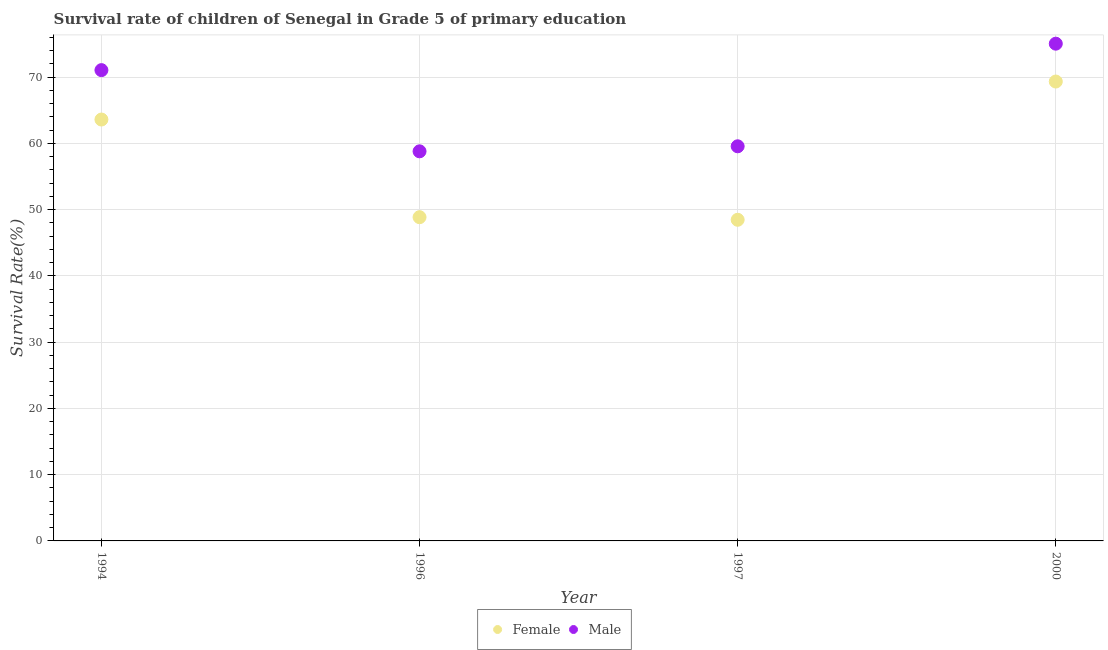How many different coloured dotlines are there?
Ensure brevity in your answer.  2. What is the survival rate of female students in primary education in 1994?
Your answer should be compact. 63.61. Across all years, what is the maximum survival rate of male students in primary education?
Provide a succinct answer. 75.06. Across all years, what is the minimum survival rate of male students in primary education?
Offer a very short reply. 58.81. In which year was the survival rate of male students in primary education maximum?
Ensure brevity in your answer.  2000. What is the total survival rate of female students in primary education in the graph?
Your response must be concise. 230.3. What is the difference between the survival rate of female students in primary education in 1994 and that in 2000?
Your answer should be compact. -5.74. What is the difference between the survival rate of male students in primary education in 2000 and the survival rate of female students in primary education in 1996?
Your response must be concise. 26.19. What is the average survival rate of male students in primary education per year?
Offer a very short reply. 66.13. In the year 1996, what is the difference between the survival rate of female students in primary education and survival rate of male students in primary education?
Your answer should be compact. -9.94. What is the ratio of the survival rate of female students in primary education in 1996 to that in 2000?
Your response must be concise. 0.7. What is the difference between the highest and the second highest survival rate of female students in primary education?
Offer a very short reply. 5.74. What is the difference between the highest and the lowest survival rate of female students in primary education?
Your answer should be very brief. 20.87. Is the survival rate of male students in primary education strictly greater than the survival rate of female students in primary education over the years?
Provide a succinct answer. Yes. Is the survival rate of female students in primary education strictly less than the survival rate of male students in primary education over the years?
Offer a terse response. Yes. What is the difference between two consecutive major ticks on the Y-axis?
Provide a succinct answer. 10. Are the values on the major ticks of Y-axis written in scientific E-notation?
Your response must be concise. No. Does the graph contain any zero values?
Provide a succinct answer. No. Where does the legend appear in the graph?
Offer a terse response. Bottom center. How are the legend labels stacked?
Your response must be concise. Horizontal. What is the title of the graph?
Ensure brevity in your answer.  Survival rate of children of Senegal in Grade 5 of primary education. What is the label or title of the X-axis?
Make the answer very short. Year. What is the label or title of the Y-axis?
Make the answer very short. Survival Rate(%). What is the Survival Rate(%) of Female in 1994?
Keep it short and to the point. 63.61. What is the Survival Rate(%) in Male in 1994?
Your answer should be compact. 71.07. What is the Survival Rate(%) in Female in 1996?
Keep it short and to the point. 48.87. What is the Survival Rate(%) of Male in 1996?
Your answer should be very brief. 58.81. What is the Survival Rate(%) of Female in 1997?
Your response must be concise. 48.48. What is the Survival Rate(%) in Male in 1997?
Keep it short and to the point. 59.57. What is the Survival Rate(%) of Female in 2000?
Your answer should be very brief. 69.34. What is the Survival Rate(%) of Male in 2000?
Offer a terse response. 75.06. Across all years, what is the maximum Survival Rate(%) of Female?
Keep it short and to the point. 69.34. Across all years, what is the maximum Survival Rate(%) in Male?
Make the answer very short. 75.06. Across all years, what is the minimum Survival Rate(%) in Female?
Your answer should be very brief. 48.48. Across all years, what is the minimum Survival Rate(%) of Male?
Make the answer very short. 58.81. What is the total Survival Rate(%) in Female in the graph?
Offer a terse response. 230.3. What is the total Survival Rate(%) of Male in the graph?
Offer a very short reply. 264.5. What is the difference between the Survival Rate(%) of Female in 1994 and that in 1996?
Offer a terse response. 14.74. What is the difference between the Survival Rate(%) in Male in 1994 and that in 1996?
Offer a terse response. 12.26. What is the difference between the Survival Rate(%) in Female in 1994 and that in 1997?
Keep it short and to the point. 15.13. What is the difference between the Survival Rate(%) of Male in 1994 and that in 1997?
Your answer should be compact. 11.5. What is the difference between the Survival Rate(%) in Female in 1994 and that in 2000?
Keep it short and to the point. -5.74. What is the difference between the Survival Rate(%) of Male in 1994 and that in 2000?
Your answer should be compact. -3.99. What is the difference between the Survival Rate(%) in Female in 1996 and that in 1997?
Your answer should be compact. 0.39. What is the difference between the Survival Rate(%) of Male in 1996 and that in 1997?
Offer a terse response. -0.76. What is the difference between the Survival Rate(%) of Female in 1996 and that in 2000?
Your answer should be compact. -20.47. What is the difference between the Survival Rate(%) in Male in 1996 and that in 2000?
Give a very brief answer. -16.25. What is the difference between the Survival Rate(%) in Female in 1997 and that in 2000?
Keep it short and to the point. -20.87. What is the difference between the Survival Rate(%) of Male in 1997 and that in 2000?
Make the answer very short. -15.49. What is the difference between the Survival Rate(%) of Female in 1994 and the Survival Rate(%) of Male in 1996?
Provide a succinct answer. 4.8. What is the difference between the Survival Rate(%) of Female in 1994 and the Survival Rate(%) of Male in 1997?
Your answer should be compact. 4.04. What is the difference between the Survival Rate(%) of Female in 1994 and the Survival Rate(%) of Male in 2000?
Your answer should be very brief. -11.45. What is the difference between the Survival Rate(%) in Female in 1996 and the Survival Rate(%) in Male in 1997?
Ensure brevity in your answer.  -10.7. What is the difference between the Survival Rate(%) in Female in 1996 and the Survival Rate(%) in Male in 2000?
Offer a very short reply. -26.19. What is the difference between the Survival Rate(%) of Female in 1997 and the Survival Rate(%) of Male in 2000?
Give a very brief answer. -26.58. What is the average Survival Rate(%) of Female per year?
Ensure brevity in your answer.  57.57. What is the average Survival Rate(%) in Male per year?
Your answer should be very brief. 66.13. In the year 1994, what is the difference between the Survival Rate(%) of Female and Survival Rate(%) of Male?
Ensure brevity in your answer.  -7.46. In the year 1996, what is the difference between the Survival Rate(%) of Female and Survival Rate(%) of Male?
Your answer should be compact. -9.94. In the year 1997, what is the difference between the Survival Rate(%) of Female and Survival Rate(%) of Male?
Your answer should be compact. -11.09. In the year 2000, what is the difference between the Survival Rate(%) of Female and Survival Rate(%) of Male?
Provide a succinct answer. -5.71. What is the ratio of the Survival Rate(%) in Female in 1994 to that in 1996?
Give a very brief answer. 1.3. What is the ratio of the Survival Rate(%) of Male in 1994 to that in 1996?
Make the answer very short. 1.21. What is the ratio of the Survival Rate(%) of Female in 1994 to that in 1997?
Give a very brief answer. 1.31. What is the ratio of the Survival Rate(%) in Male in 1994 to that in 1997?
Provide a succinct answer. 1.19. What is the ratio of the Survival Rate(%) in Female in 1994 to that in 2000?
Your response must be concise. 0.92. What is the ratio of the Survival Rate(%) in Male in 1994 to that in 2000?
Your response must be concise. 0.95. What is the ratio of the Survival Rate(%) in Female in 1996 to that in 1997?
Offer a terse response. 1.01. What is the ratio of the Survival Rate(%) in Male in 1996 to that in 1997?
Your answer should be very brief. 0.99. What is the ratio of the Survival Rate(%) in Female in 1996 to that in 2000?
Give a very brief answer. 0.7. What is the ratio of the Survival Rate(%) in Male in 1996 to that in 2000?
Keep it short and to the point. 0.78. What is the ratio of the Survival Rate(%) in Female in 1997 to that in 2000?
Give a very brief answer. 0.7. What is the ratio of the Survival Rate(%) of Male in 1997 to that in 2000?
Make the answer very short. 0.79. What is the difference between the highest and the second highest Survival Rate(%) in Female?
Your answer should be compact. 5.74. What is the difference between the highest and the second highest Survival Rate(%) in Male?
Provide a short and direct response. 3.99. What is the difference between the highest and the lowest Survival Rate(%) of Female?
Keep it short and to the point. 20.87. What is the difference between the highest and the lowest Survival Rate(%) in Male?
Your answer should be compact. 16.25. 